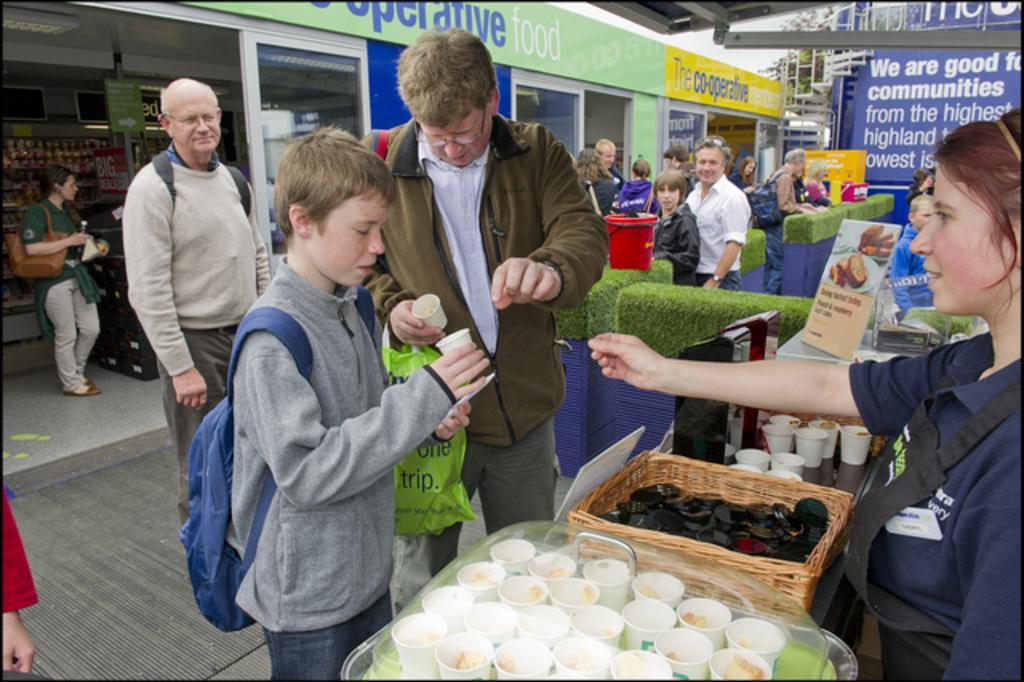In one or two sentences, can you explain what this image depicts? In this picture there are two persons standing and holding the cups. At the back there are group of people standing. There are cups in the tray and there are objects in the basket and there are cups, boards on the table. At the back there are boards on the wall and there is a staircase. At the top there is sky and at the back there is a tree. On the left side of the image there are objects in the cupboard and at the top there is a light. 